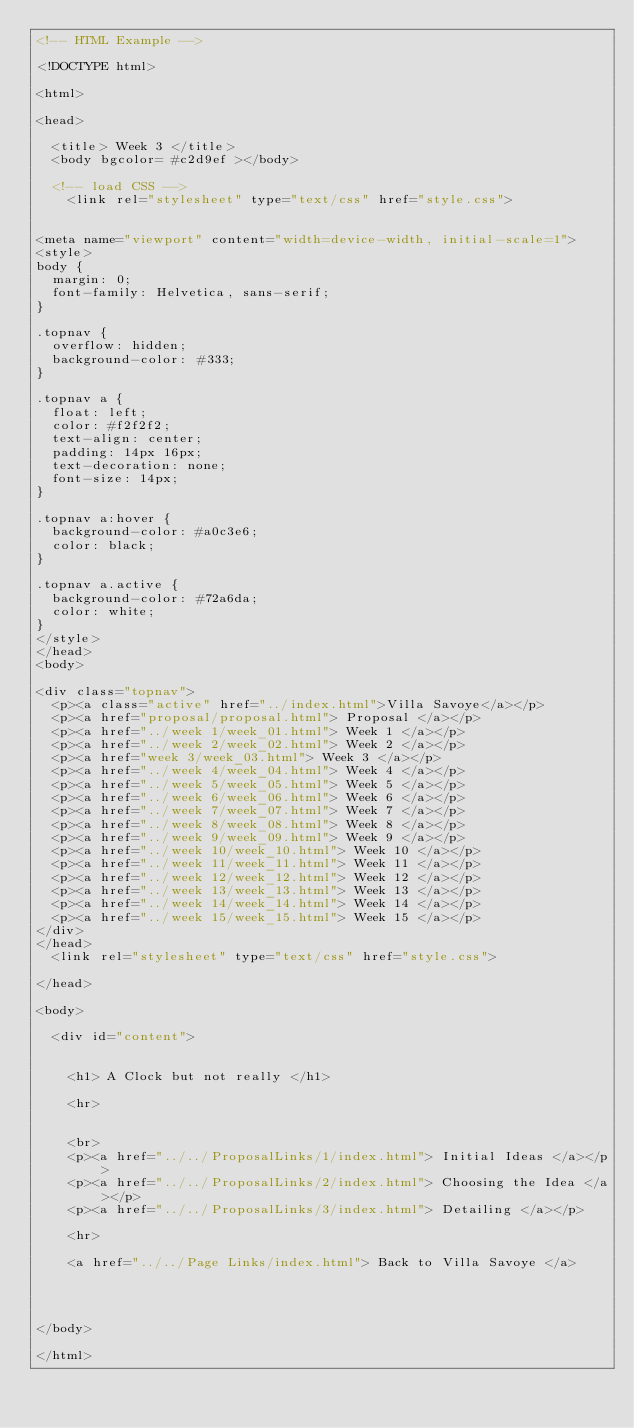<code> <loc_0><loc_0><loc_500><loc_500><_HTML_><!-- HTML Example -->

<!DOCTYPE html>

<html>

<head>

	<title> Week 3 </title>
	<body bgcolor= #c2d9ef ></body>

	<!-- load CSS -->
		<link rel="stylesheet" type="text/css" href="style.css"> 


<meta name="viewport" content="width=device-width, initial-scale=1">
<style>
body {
  margin: 0;
  font-family: Helvetica, sans-serif;
}

.topnav {
  overflow: hidden;
  background-color: #333;
}

.topnav a {
  float: left;
  color: #f2f2f2;
  text-align: center;
  padding: 14px 16px;
  text-decoration: none;
  font-size: 14px;
}

.topnav a:hover {
  background-color: #a0c3e6;
  color: black;
}

.topnav a.active {
  background-color: #72a6da;
  color: white;
}
</style>
</head>
<body>
	
<div class="topnav">
 	<p><a class="active" href="../index.html">Villa Savoye</a></p>
 	<p><a href="proposal/proposal.html"> Proposal </a></p>
	<p><a href="../week 1/week_01.html"> Week 1 </a></p>
	<p><a href="../week 2/week_02.html"> Week 2 </a></p>
	<p><a href="week 3/week_03.html"> Week 3 </a></p>
	<p><a href="../week 4/week_04.html"> Week 4 </a></p>
	<p><a href="../week 5/week_05.html"> Week 5 </a></p>
	<p><a href="../week 6/week_06.html"> Week 6 </a></p>
	<p><a href="../week 7/week_07.html"> Week 7 </a></p>
	<p><a href="../week 8/week_08.html"> Week 8 </a></p>
	<p><a href="../week 9/week_09.html"> Week 9 </a></p>
	<p><a href="../week 10/week_10.html"> Week 10 </a></p>
	<p><a href="../week 11/week_11.html"> Week 11 </a></p>
	<p><a href="../week 12/week_12.html"> Week 12 </a></p>
	<p><a href="../week 13/week_13.html"> Week 13 </a></p>
	<p><a href="../week 14/week_14.html"> Week 14 </a></p>
	<p><a href="../week 15/week_15.html"> Week 15 </a></p>
</div>
</head>
	<link rel="stylesheet" type="text/css" href="style.css"> 

</head>

<body>

	<div id="content">


		<h1> A Clock but not really </h1>
		
		<hr>


		<br>
		<p><a href="../../ProposalLinks/1/index.html"> Initial Ideas </a></p>
		<p><a href="../../ProposalLinks/2/index.html"> Choosing the Idea </a></p>
		<p><a href="../../ProposalLinks/3/index.html"> Detailing </a></p>
	
		<hr>
		
		<a href="../../Page Links/index.html"> Back to Villa Savoye </a>


	

</body>

</html>




















</code> 